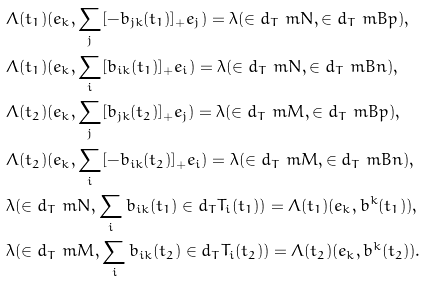Convert formula to latex. <formula><loc_0><loc_0><loc_500><loc_500>& \Lambda ( t _ { 1 } ) ( e _ { k } , \sum _ { j } [ - b _ { j k } ( t _ { 1 } ) ] _ { + } e _ { j } ) = \lambda ( { \in d _ { T } \ m N } , { \in d _ { T } \ m B p } ) , \\ & \Lambda ( t _ { 1 } ) ( e _ { k } , \sum _ { i } [ b _ { i k } ( t _ { 1 } ) ] _ { + } e _ { i } ) = \lambda ( { \in d _ { T } \ m N } , { \in d _ { T } \ m B n } ) , \\ & \Lambda ( t _ { 2 } ) ( e _ { k } , \sum _ { j } [ b _ { j k } ( t _ { 2 } ) ] _ { + } e _ { j } ) = \lambda ( { \in d _ { T } \ m M } , { \in d _ { T } \ m B p } ) , \\ & \Lambda ( t _ { 2 } ) ( e _ { k } , \sum _ { i } [ - b _ { i k } ( t _ { 2 } ) ] _ { + } e _ { i } ) = \lambda ( { \in d _ { T } \ m M } , { \in d _ { T } \ m B n } ) , \\ & \lambda ( { \in d _ { T } \ m N } , \sum _ { i } b _ { i k } ( t _ { 1 } ) \in d _ { T } T _ { i } ( t _ { 1 } ) ) = \Lambda ( t _ { 1 } ) ( e _ { k } , b ^ { k } ( t _ { 1 } ) ) , \\ & \lambda ( { \in d _ { T } \ m M } , \sum _ { i } b _ { i k } ( t _ { 2 } ) \in d _ { T } T _ { i } ( t _ { 2 } ) ) = \Lambda ( t _ { 2 } ) ( e _ { k } , b ^ { k } ( t _ { 2 } ) ) .</formula> 